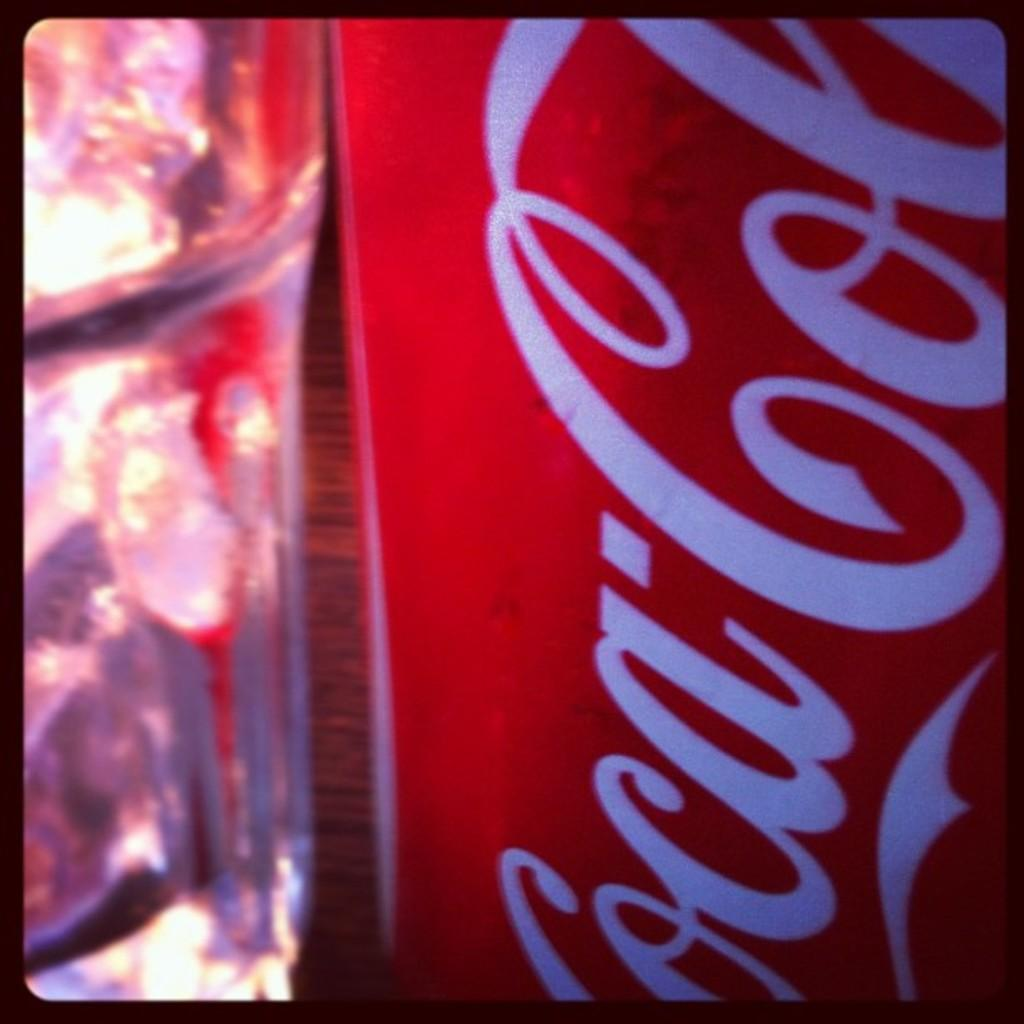What type of image is being described? The image is an edited picture. What can be seen inside the image? There is a glass in the image. What is unique about the glass? The glass has a label. What information is on the label? There is text on the label. What type of surface is at the bottom of the image? There is a wooden floor at the bottom of the image. How many feet are visible in the image? There are no feet visible in the image; it only features a glass with a label and a wooden floor. 